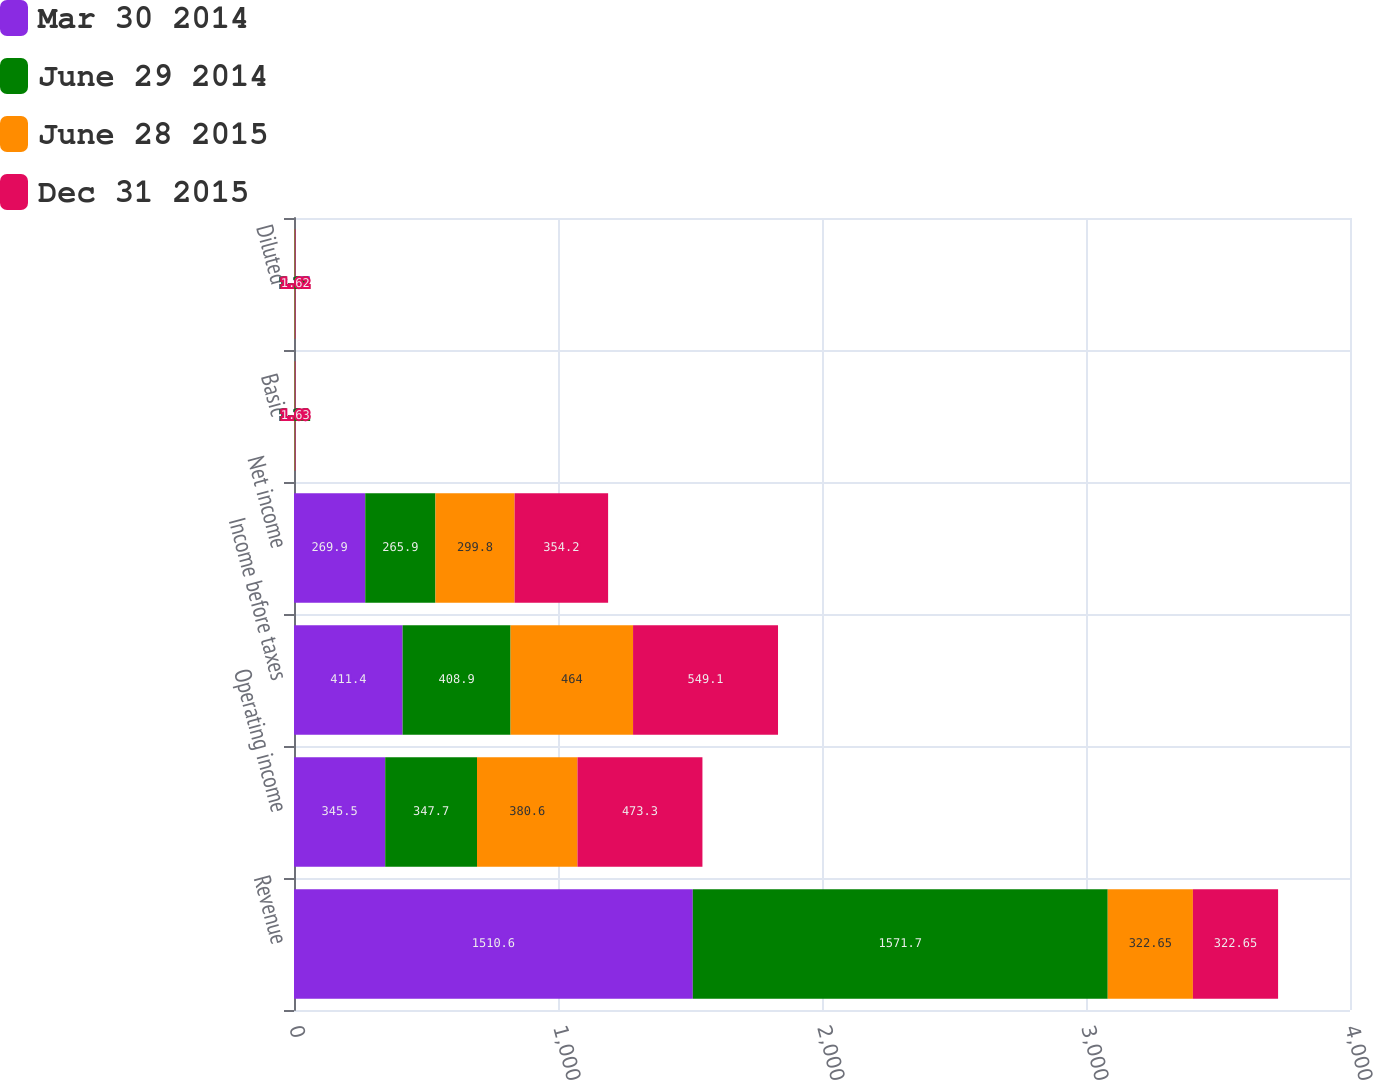Convert chart to OTSL. <chart><loc_0><loc_0><loc_500><loc_500><stacked_bar_chart><ecel><fcel>Revenue<fcel>Operating income<fcel>Income before taxes<fcel>Net income<fcel>Basic<fcel>Diluted<nl><fcel>Mar 30 2014<fcel>1510.6<fcel>345.5<fcel>411.4<fcel>269.9<fcel>1.28<fcel>1.27<nl><fcel>June 29 2014<fcel>1571.7<fcel>347.7<fcel>408.9<fcel>265.9<fcel>1.21<fcel>1.21<nl><fcel>June 28 2015<fcel>322.65<fcel>380.6<fcel>464<fcel>299.8<fcel>1.44<fcel>1.44<nl><fcel>Dec 31 2015<fcel>322.65<fcel>473.3<fcel>549.1<fcel>354.2<fcel>1.63<fcel>1.62<nl></chart> 